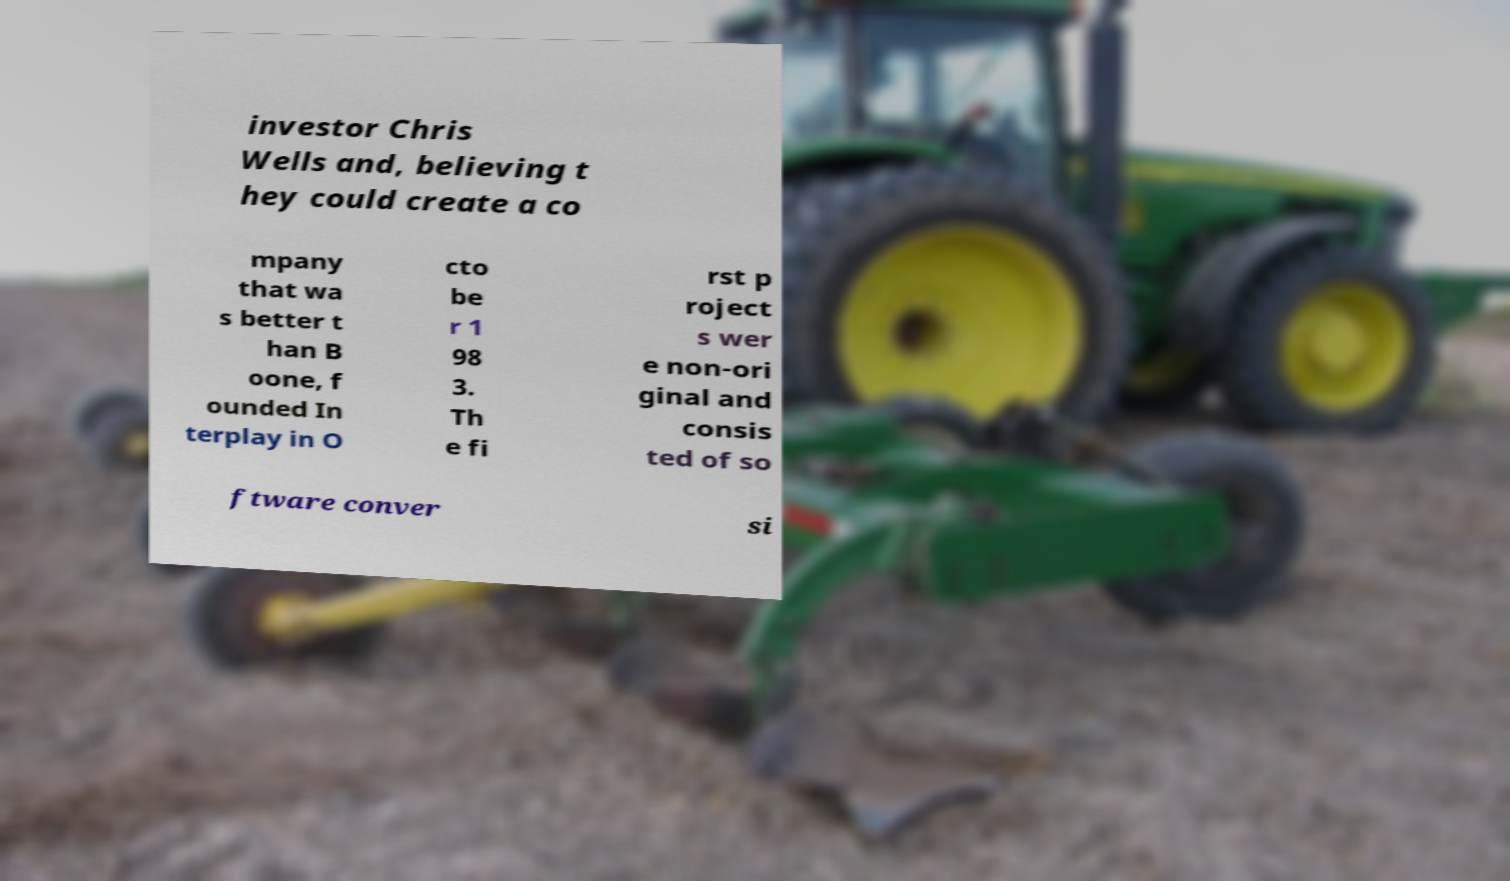Can you accurately transcribe the text from the provided image for me? investor Chris Wells and, believing t hey could create a co mpany that wa s better t han B oone, f ounded In terplay in O cto be r 1 98 3. Th e fi rst p roject s wer e non-ori ginal and consis ted of so ftware conver si 